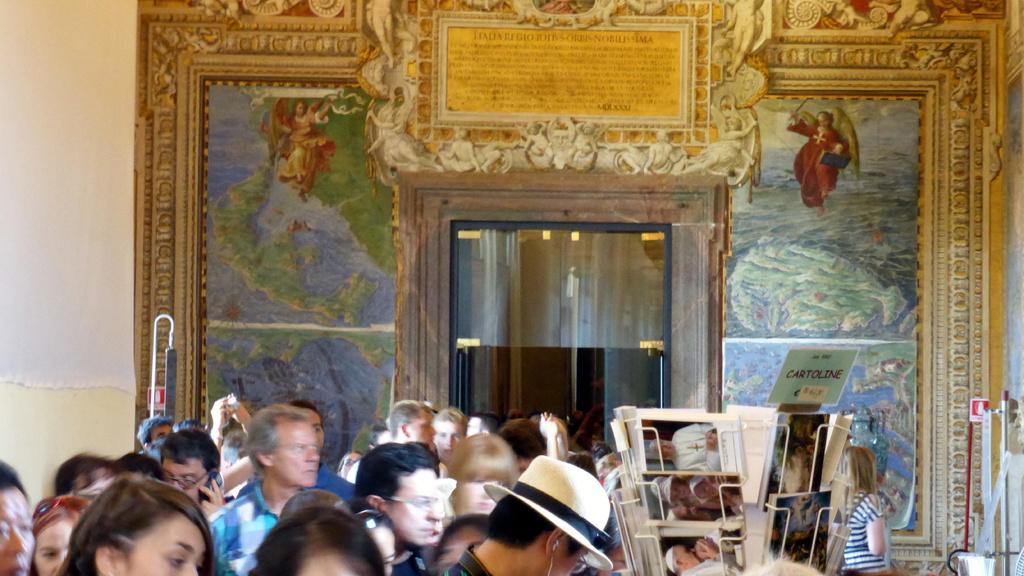How would you summarize this image in a sentence or two? In the image there are many people standing on the floor, there is a book rack in the middle and in the back there is wall with paintings and glass door in the middle of it. 